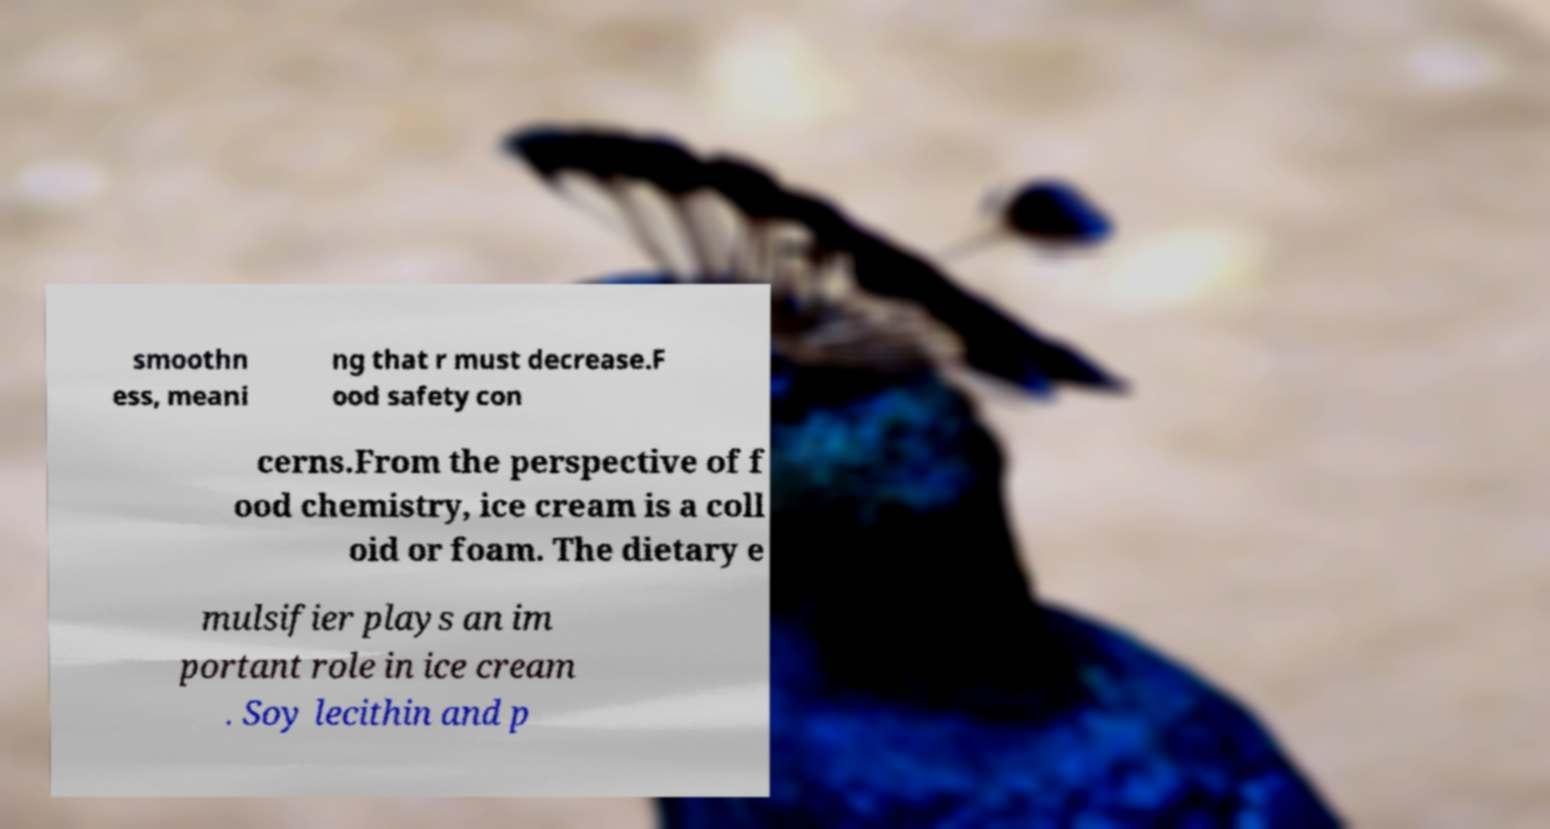Please identify and transcribe the text found in this image. smoothn ess, meani ng that r must decrease.F ood safety con cerns.From the perspective of f ood chemistry, ice cream is a coll oid or foam. The dietary e mulsifier plays an im portant role in ice cream . Soy lecithin and p 